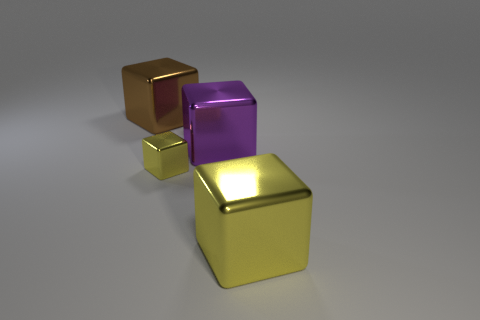Does the big brown object have the same material as the large cube in front of the purple cube?
Your answer should be compact. Yes. What material is the big object that is the same color as the tiny shiny thing?
Provide a short and direct response. Metal. What number of large blocks are the same color as the small cube?
Your answer should be very brief. 1. What is the size of the purple metallic cube?
Keep it short and to the point. Large. Does the big purple metal object have the same shape as the yellow shiny thing that is right of the purple thing?
Provide a short and direct response. Yes. How big is the yellow cube that is behind the large yellow metal object?
Your answer should be very brief. Small. Are there fewer big purple metallic objects to the left of the big purple thing than tiny matte cylinders?
Offer a very short reply. No. Is there anything else that has the same shape as the large yellow shiny thing?
Your answer should be compact. Yes. Are there fewer green objects than brown cubes?
Give a very brief answer. Yes. The tiny metal cube to the left of the yellow cube that is right of the small object is what color?
Offer a terse response. Yellow. 